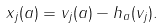Convert formula to latex. <formula><loc_0><loc_0><loc_500><loc_500>x _ { j } ( a ) = v _ { j } ( a ) - h _ { a } ( v _ { j } ) .</formula> 